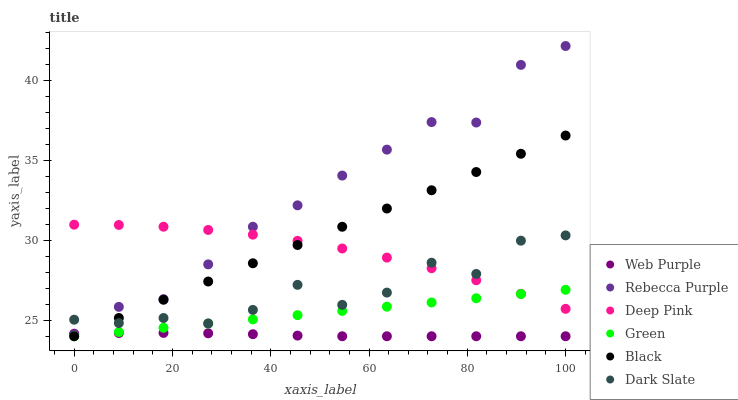Does Web Purple have the minimum area under the curve?
Answer yes or no. Yes. Does Rebecca Purple have the maximum area under the curve?
Answer yes or no. Yes. Does Dark Slate have the minimum area under the curve?
Answer yes or no. No. Does Dark Slate have the maximum area under the curve?
Answer yes or no. No. Is Green the smoothest?
Answer yes or no. Yes. Is Dark Slate the roughest?
Answer yes or no. Yes. Is Web Purple the smoothest?
Answer yes or no. No. Is Web Purple the roughest?
Answer yes or no. No. Does Web Purple have the lowest value?
Answer yes or no. Yes. Does Dark Slate have the lowest value?
Answer yes or no. No. Does Rebecca Purple have the highest value?
Answer yes or no. Yes. Does Dark Slate have the highest value?
Answer yes or no. No. Is Green less than Rebecca Purple?
Answer yes or no. Yes. Is Rebecca Purple greater than Black?
Answer yes or no. Yes. Does Black intersect Deep Pink?
Answer yes or no. Yes. Is Black less than Deep Pink?
Answer yes or no. No. Is Black greater than Deep Pink?
Answer yes or no. No. Does Green intersect Rebecca Purple?
Answer yes or no. No. 